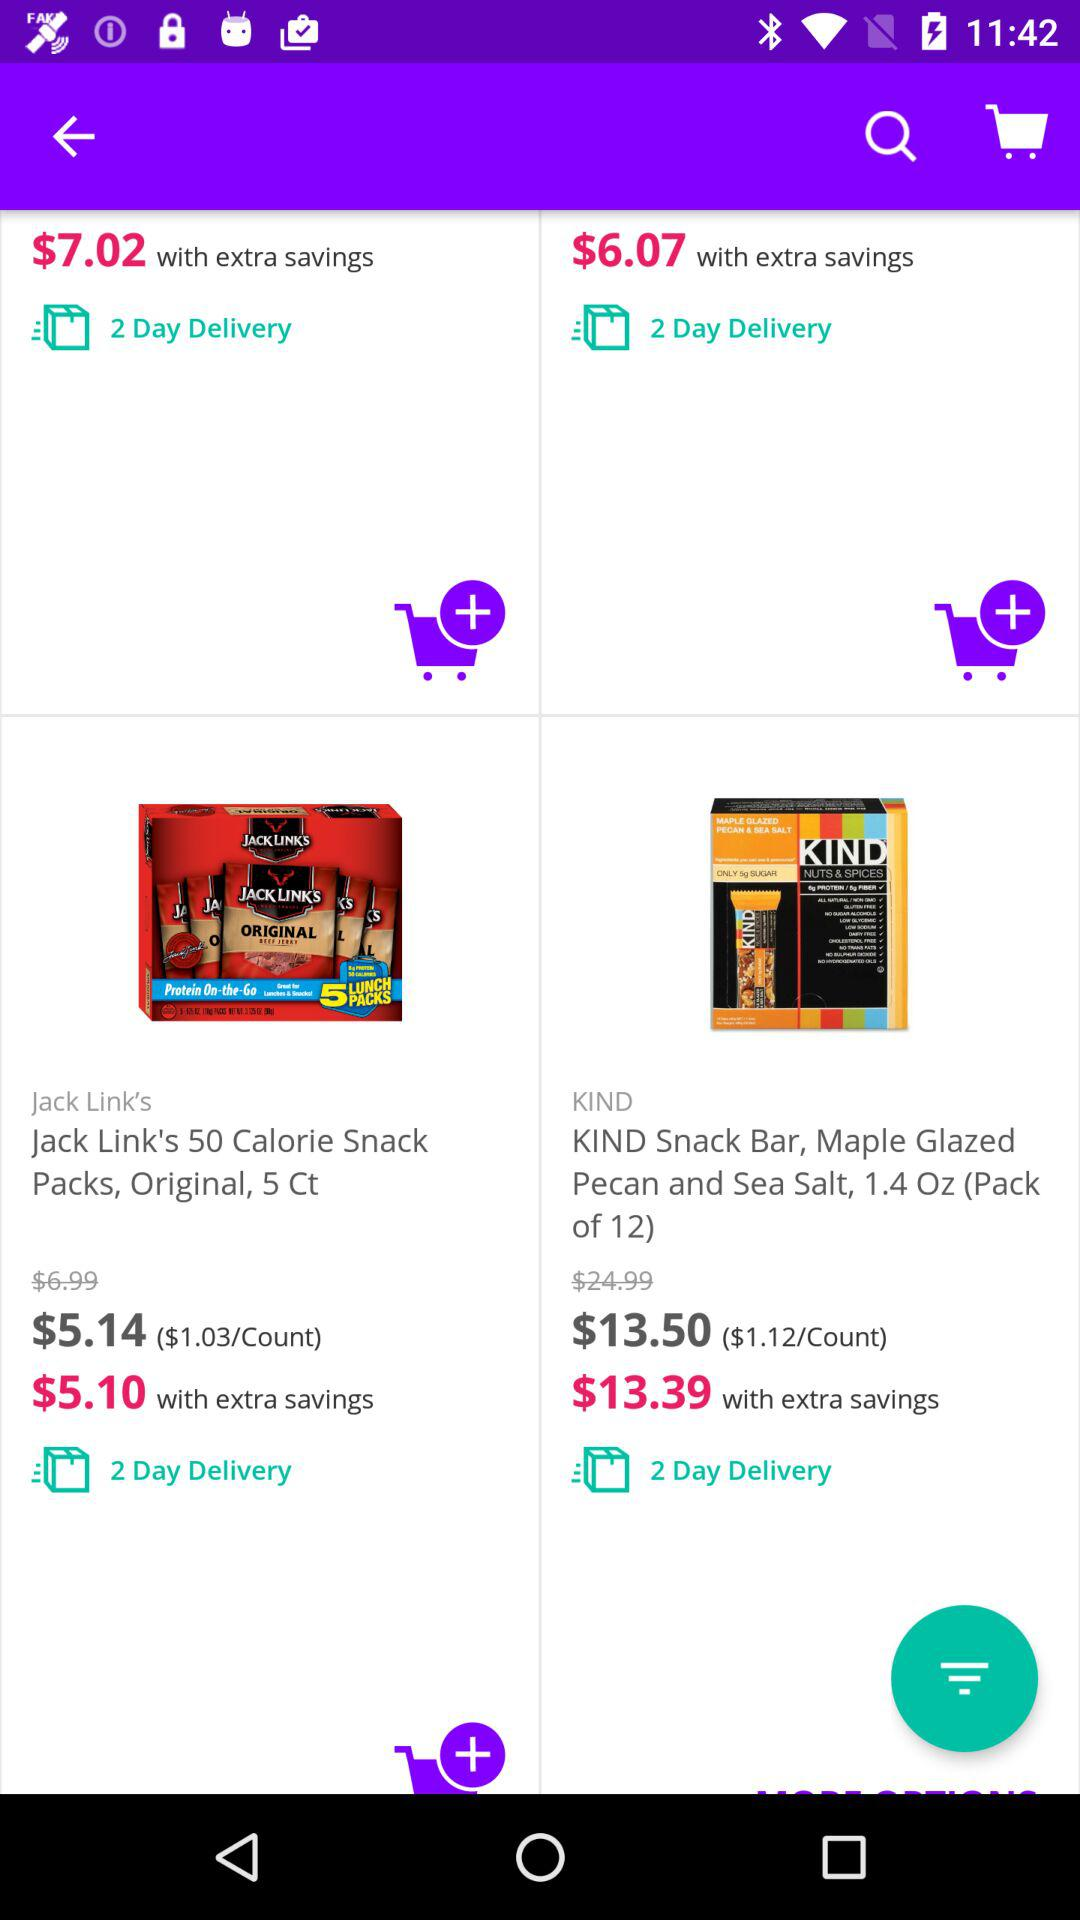In how many days will "Jack Link's 50 Calorie Snack Packs, Original, 5 Ct" be delivered? "Jack Link's 50 Calorie Snack Packs, Original, 5 Ct" will be delivered in 2 days. 